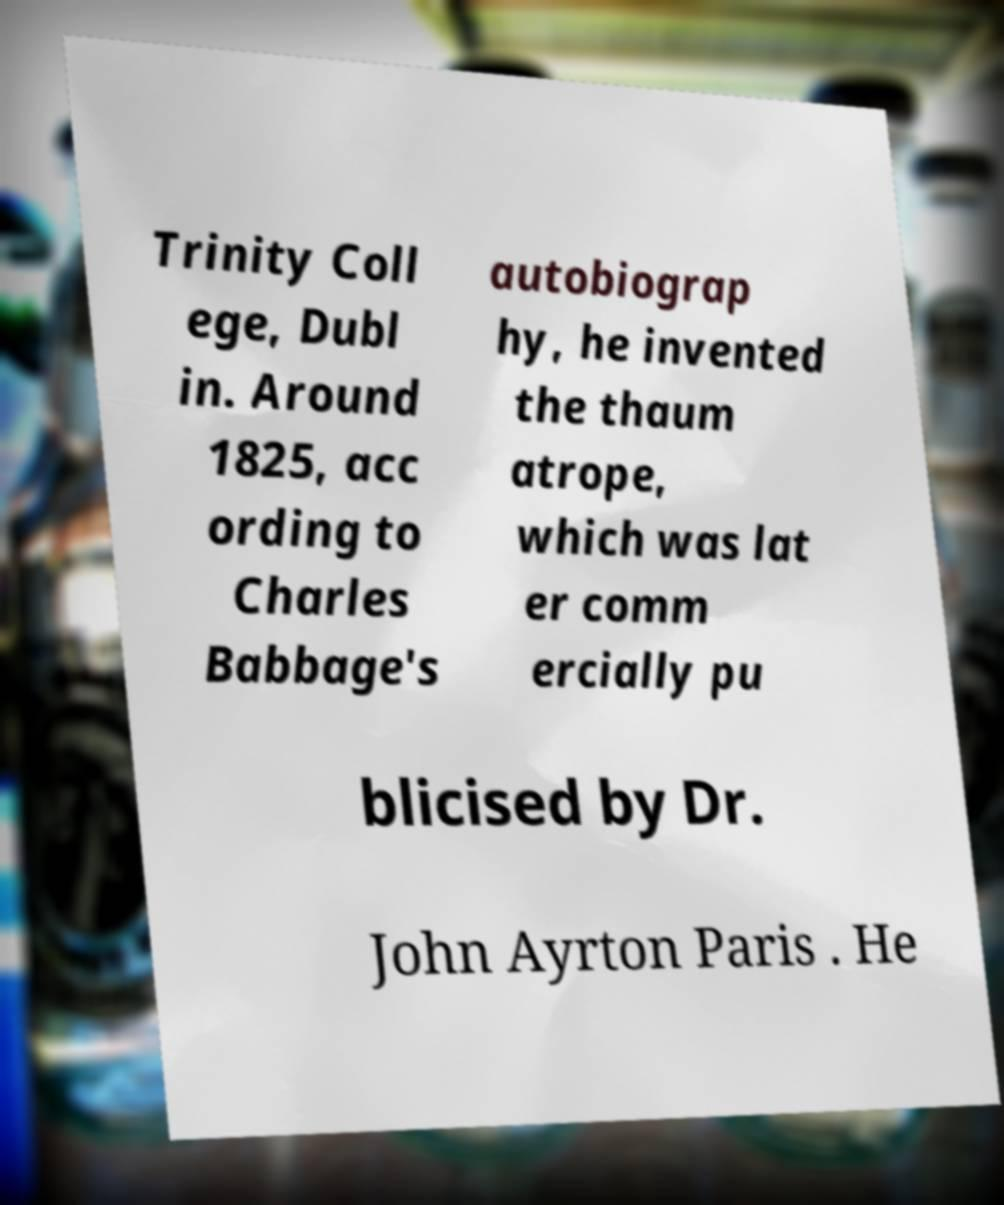Can you accurately transcribe the text from the provided image for me? Trinity Coll ege, Dubl in. Around 1825, acc ording to Charles Babbage's autobiograp hy, he invented the thaum atrope, which was lat er comm ercially pu blicised by Dr. John Ayrton Paris . He 